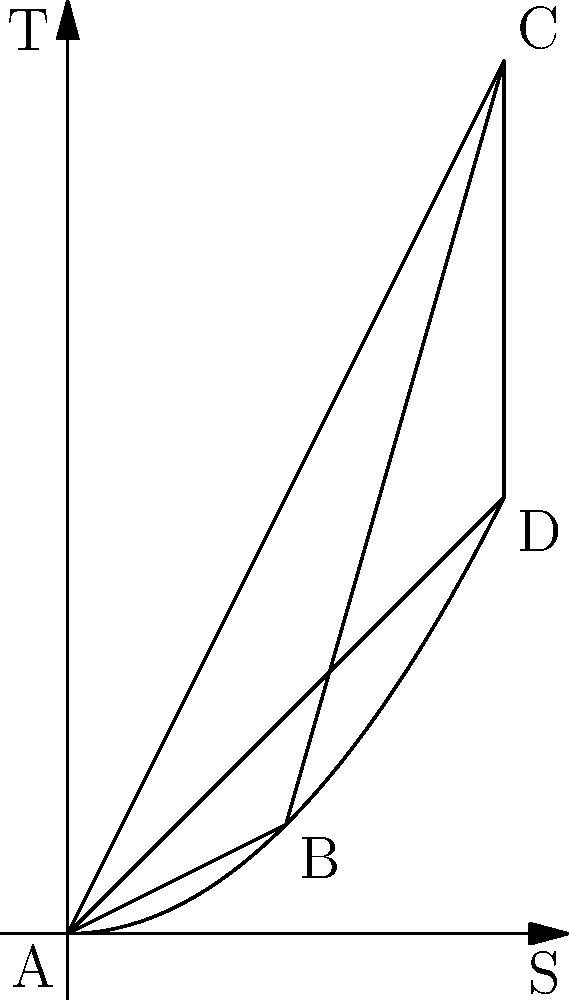In the temperature-entropy (T-S) diagram shown above, a heat engine operates in a cycle ABCDA. The curve BC represents an isothermal process. Calculate the efficiency of this heat engine. To determine the efficiency of the heat engine, we need to follow these steps:

1. Recall the formula for heat engine efficiency:
   $$\eta = 1 - \frac{Q_c}{Q_h}$$
   where $Q_c$ is the heat rejected to the cold reservoir and $Q_h$ is the heat absorbed from the hot reservoir.

2. In a T-S diagram, the area under a curve represents heat transfer. The heat absorbed ($Q_h$) is the area under curve BC, and the heat rejected ($Q_c$) is the area under curve DA.

3. Area under BC (heat absorbed):
   $$Q_h = T_h \Delta S = 4 \cdot 2 = 8$$

4. Area under DA (heat rejected):
   $$Q_c = T_c \Delta S = 2 \cdot 2 = 4$$

5. Calculate the efficiency:
   $$\eta = 1 - \frac{Q_c}{Q_h} = 1 - \frac{4}{8} = 1 - 0.5 = 0.5$$

6. Convert to percentage:
   $$\eta = 0.5 \cdot 100\% = 50\%$$

Therefore, the efficiency of the heat engine is 50%.
Answer: 50% 